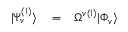<formula> <loc_0><loc_0><loc_500><loc_500>\begin{array} { r l r } { | \Psi _ { v } ^ { ( 1 ) } \rangle } & = } & { \Omega ^ { v ( 1 ) } | \Phi _ { v } \rangle } \end{array}</formula> 